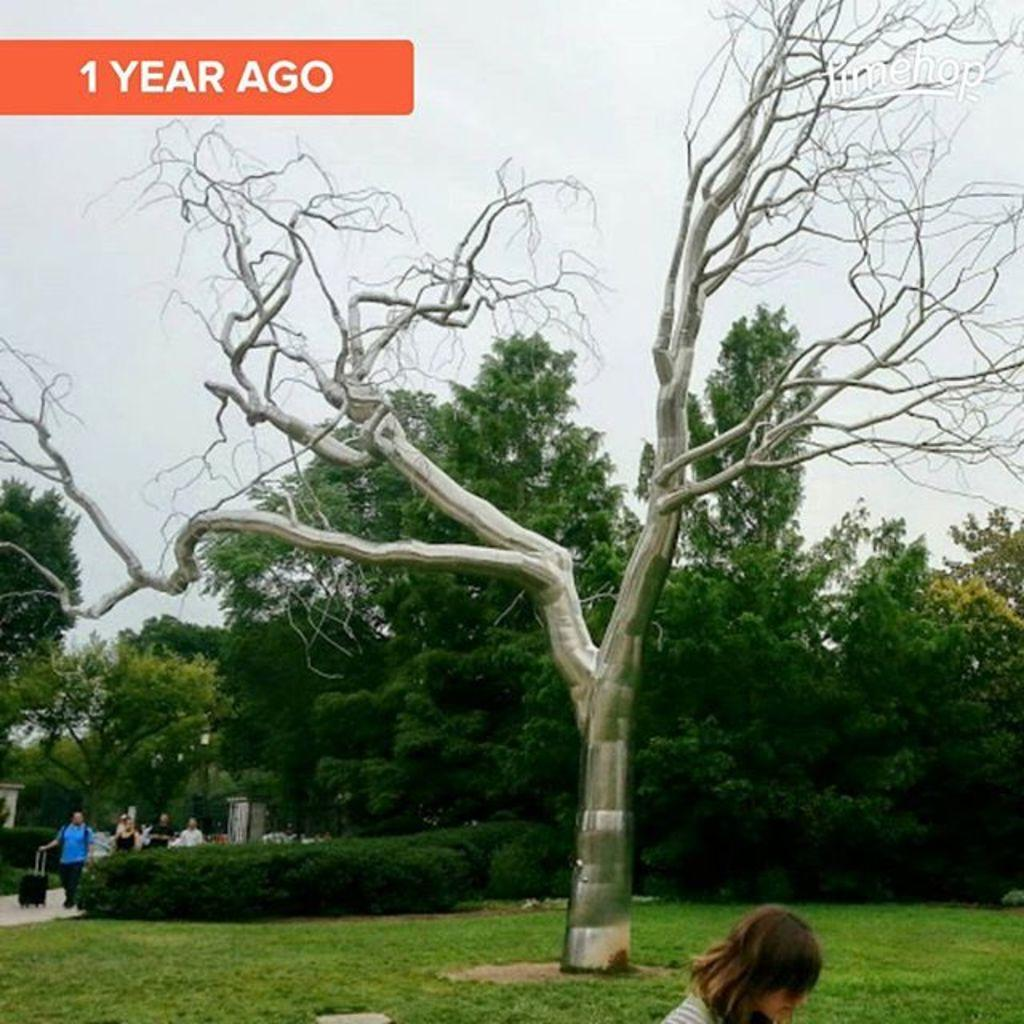What type of vegetation is in the middle of the image? There are trees in the middle of the image. What can be seen at the top of the image? There is sky visible at the top of the image. Who or what is also present in the middle of the image? There are persons in the middle of the image. What type of ground surface is at the bottom of the image? There is grass at the bottom of the image. Can you see a giraffe in the image? No, there is no giraffe present in the image. What type of beam is holding up the sky in the image? The sky is not being held up by a beam in the image; it is a natural phenomenon. 